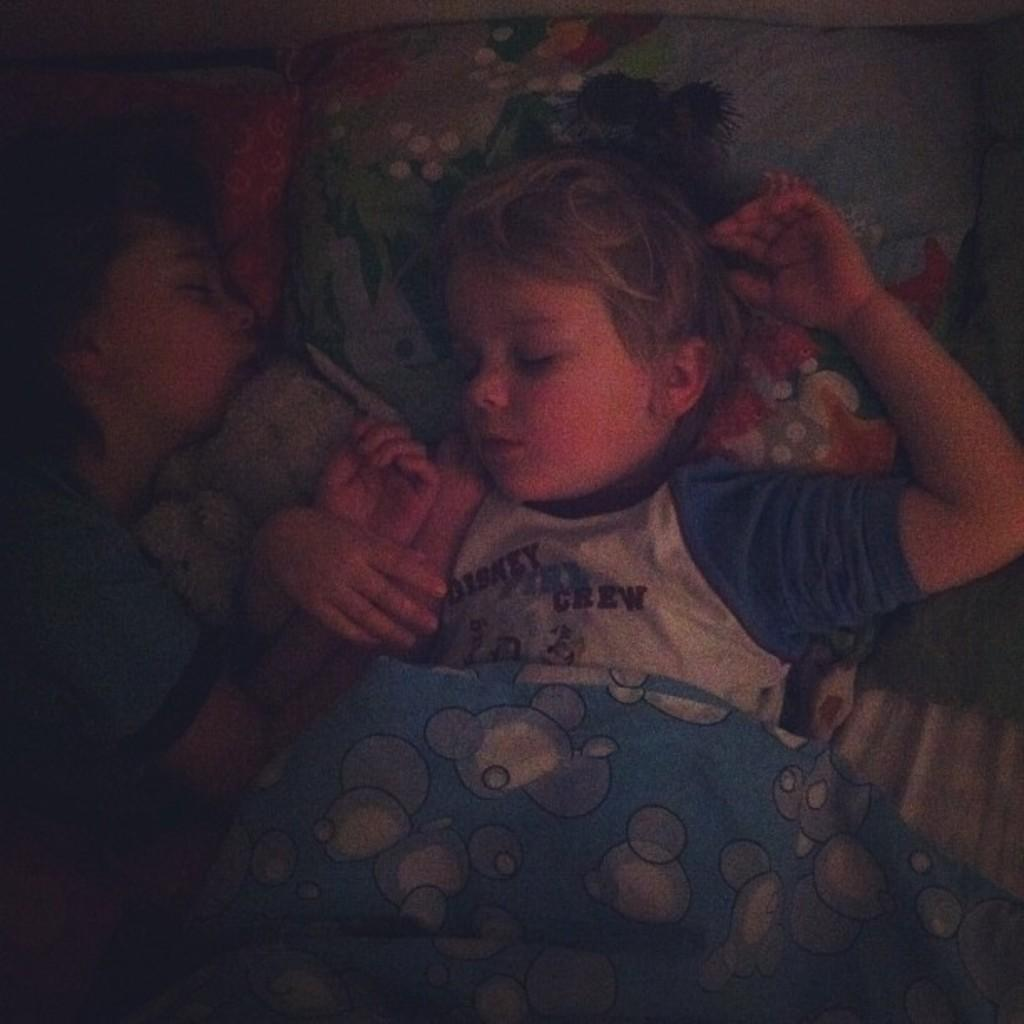How many children are present in the image? There are two kids in the image. What are the kids doing in the image? The kids are sleeping. Where are the kids located in the image? The kids are on a bed. What level of the building are the kids sleeping on in the image? There is no information about the building or the level in the image, as it only shows two kids sleeping on a bed. 